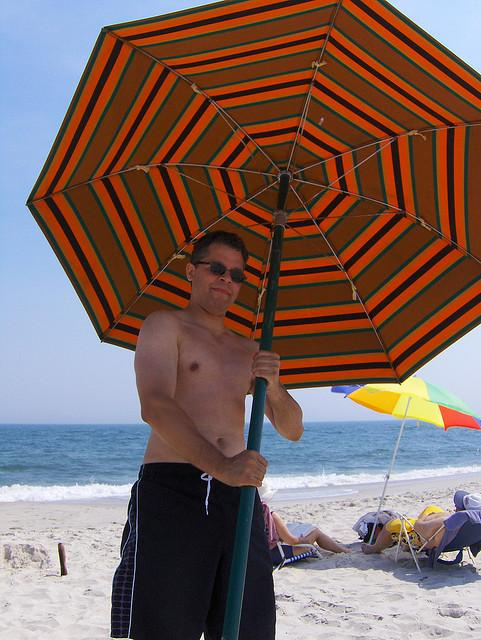If he is going to step out from under this structure he should put on what?

Choices:
A) sunblock
B) shoes
C) suit
D) music sunblock 